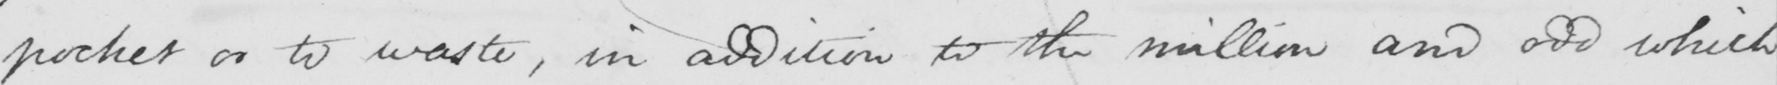What does this handwritten line say? pocket or to waste , in addition to the million and odd which 